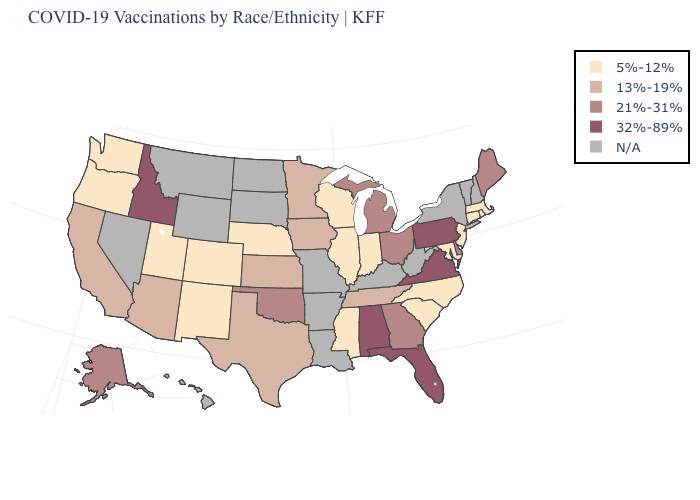Does the map have missing data?
Give a very brief answer. Yes. What is the value of Nebraska?
Be succinct. 5%-12%. How many symbols are there in the legend?
Short answer required. 5. What is the value of Georgia?
Short answer required. 21%-31%. Does Wisconsin have the lowest value in the USA?
Answer briefly. Yes. What is the highest value in states that border Colorado?
Quick response, please. 21%-31%. What is the lowest value in the USA?
Short answer required. 5%-12%. What is the value of Pennsylvania?
Give a very brief answer. 32%-89%. Which states hav the highest value in the South?
Be succinct. Alabama, Florida, Virginia. Does the first symbol in the legend represent the smallest category?
Give a very brief answer. Yes. Is the legend a continuous bar?
Keep it brief. No. What is the value of Mississippi?
Keep it brief. 5%-12%. What is the lowest value in the USA?
Answer briefly. 5%-12%. Which states have the highest value in the USA?
Concise answer only. Alabama, Florida, Idaho, Pennsylvania, Virginia. 